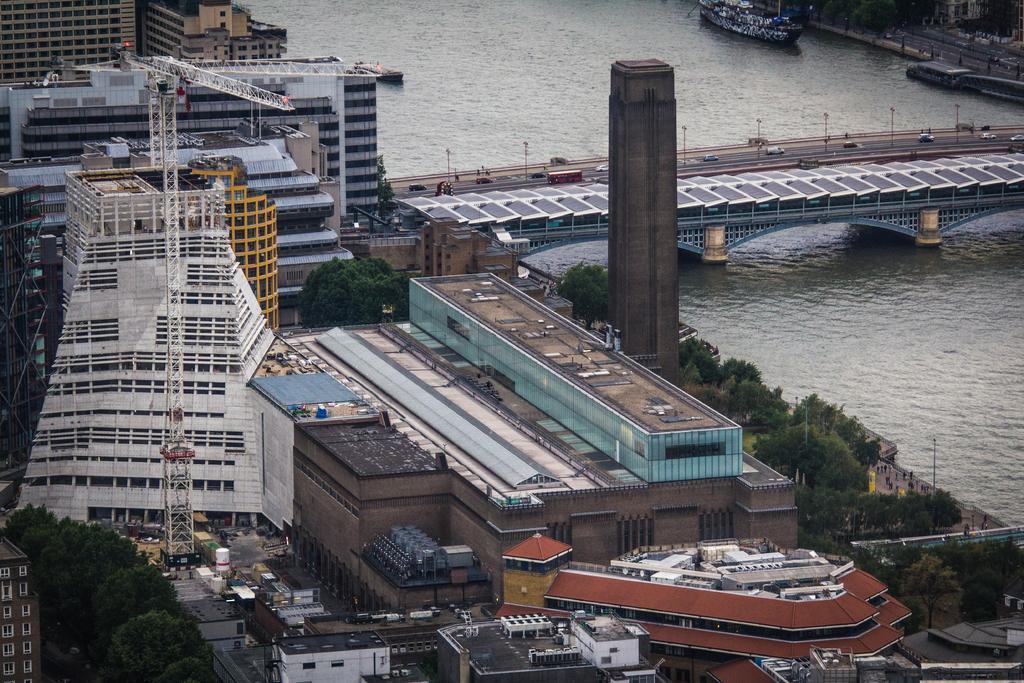Can you describe this image briefly? This is the aerial view of some buildings, road, trees, bridge, water and some boats which are moving on water. 